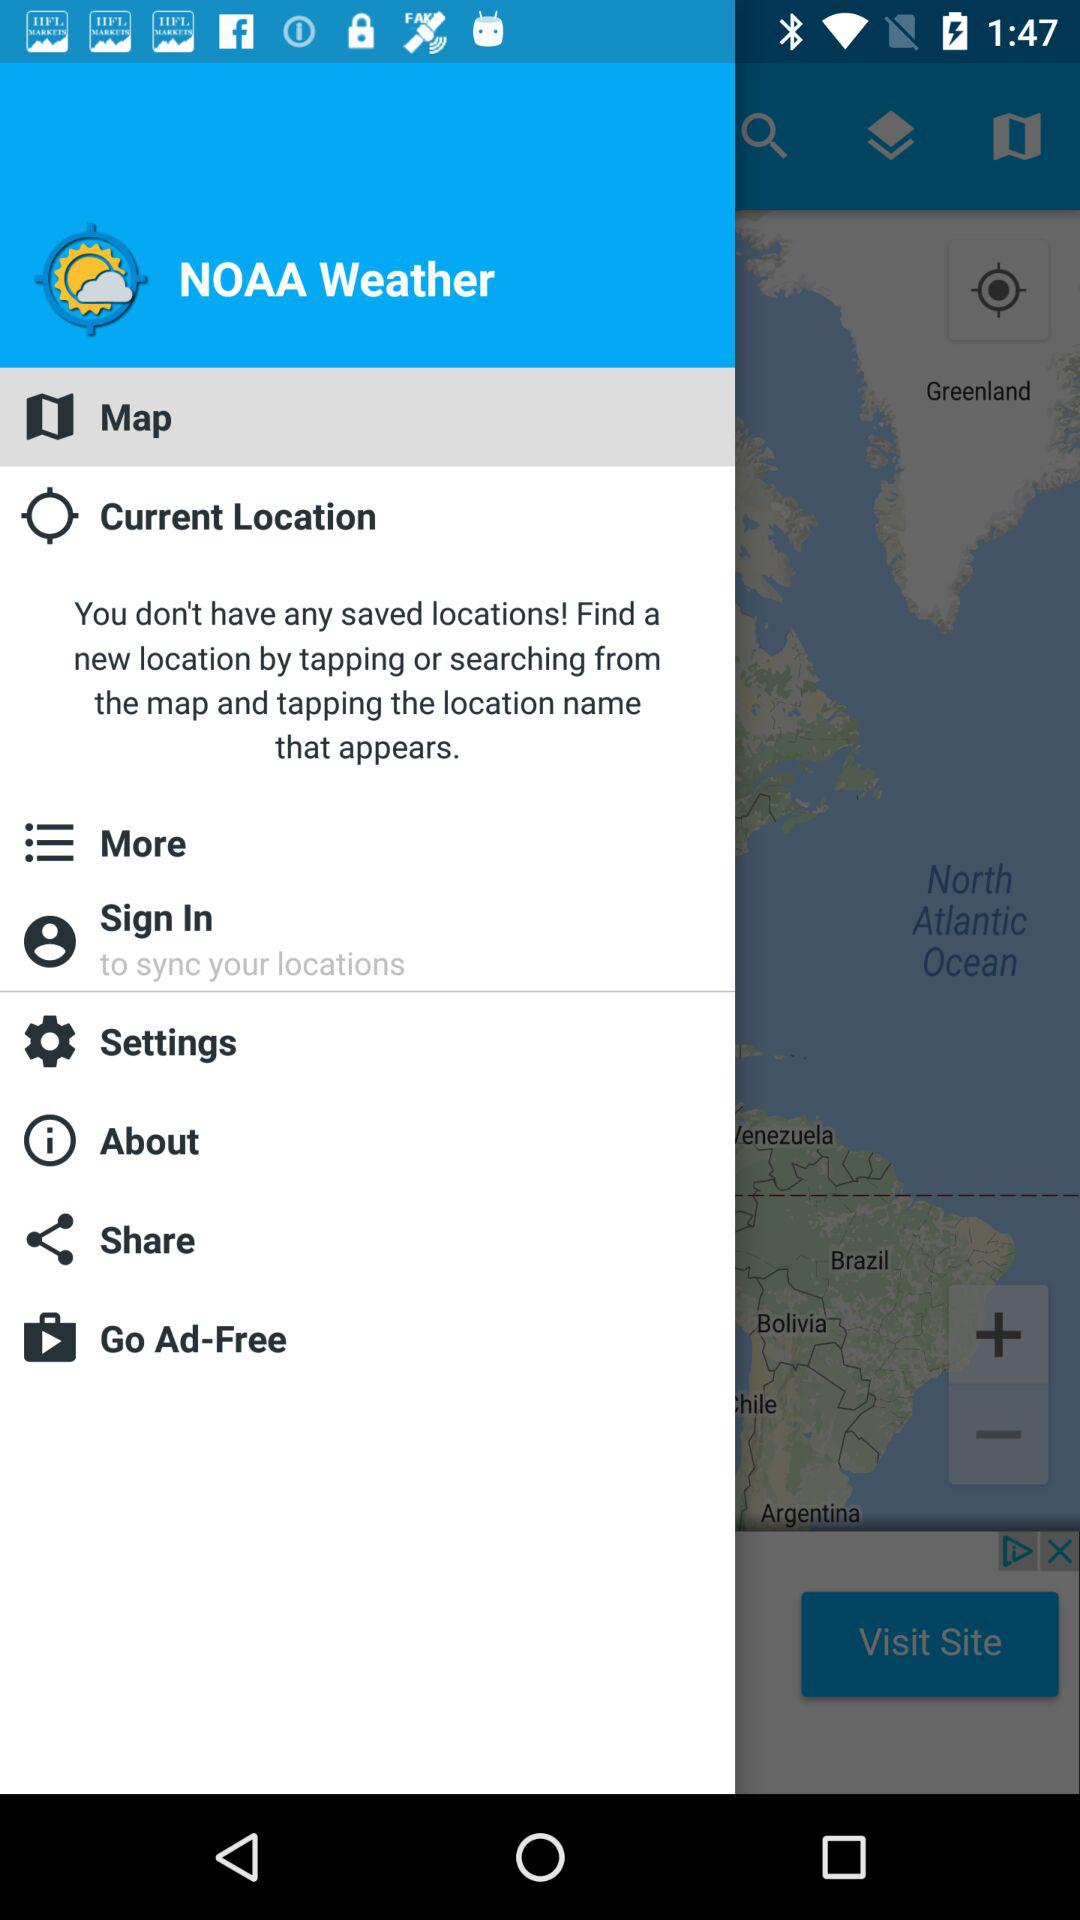By which name profile is log in?
When the provided information is insufficient, respond with <no answer>. <no answer> 